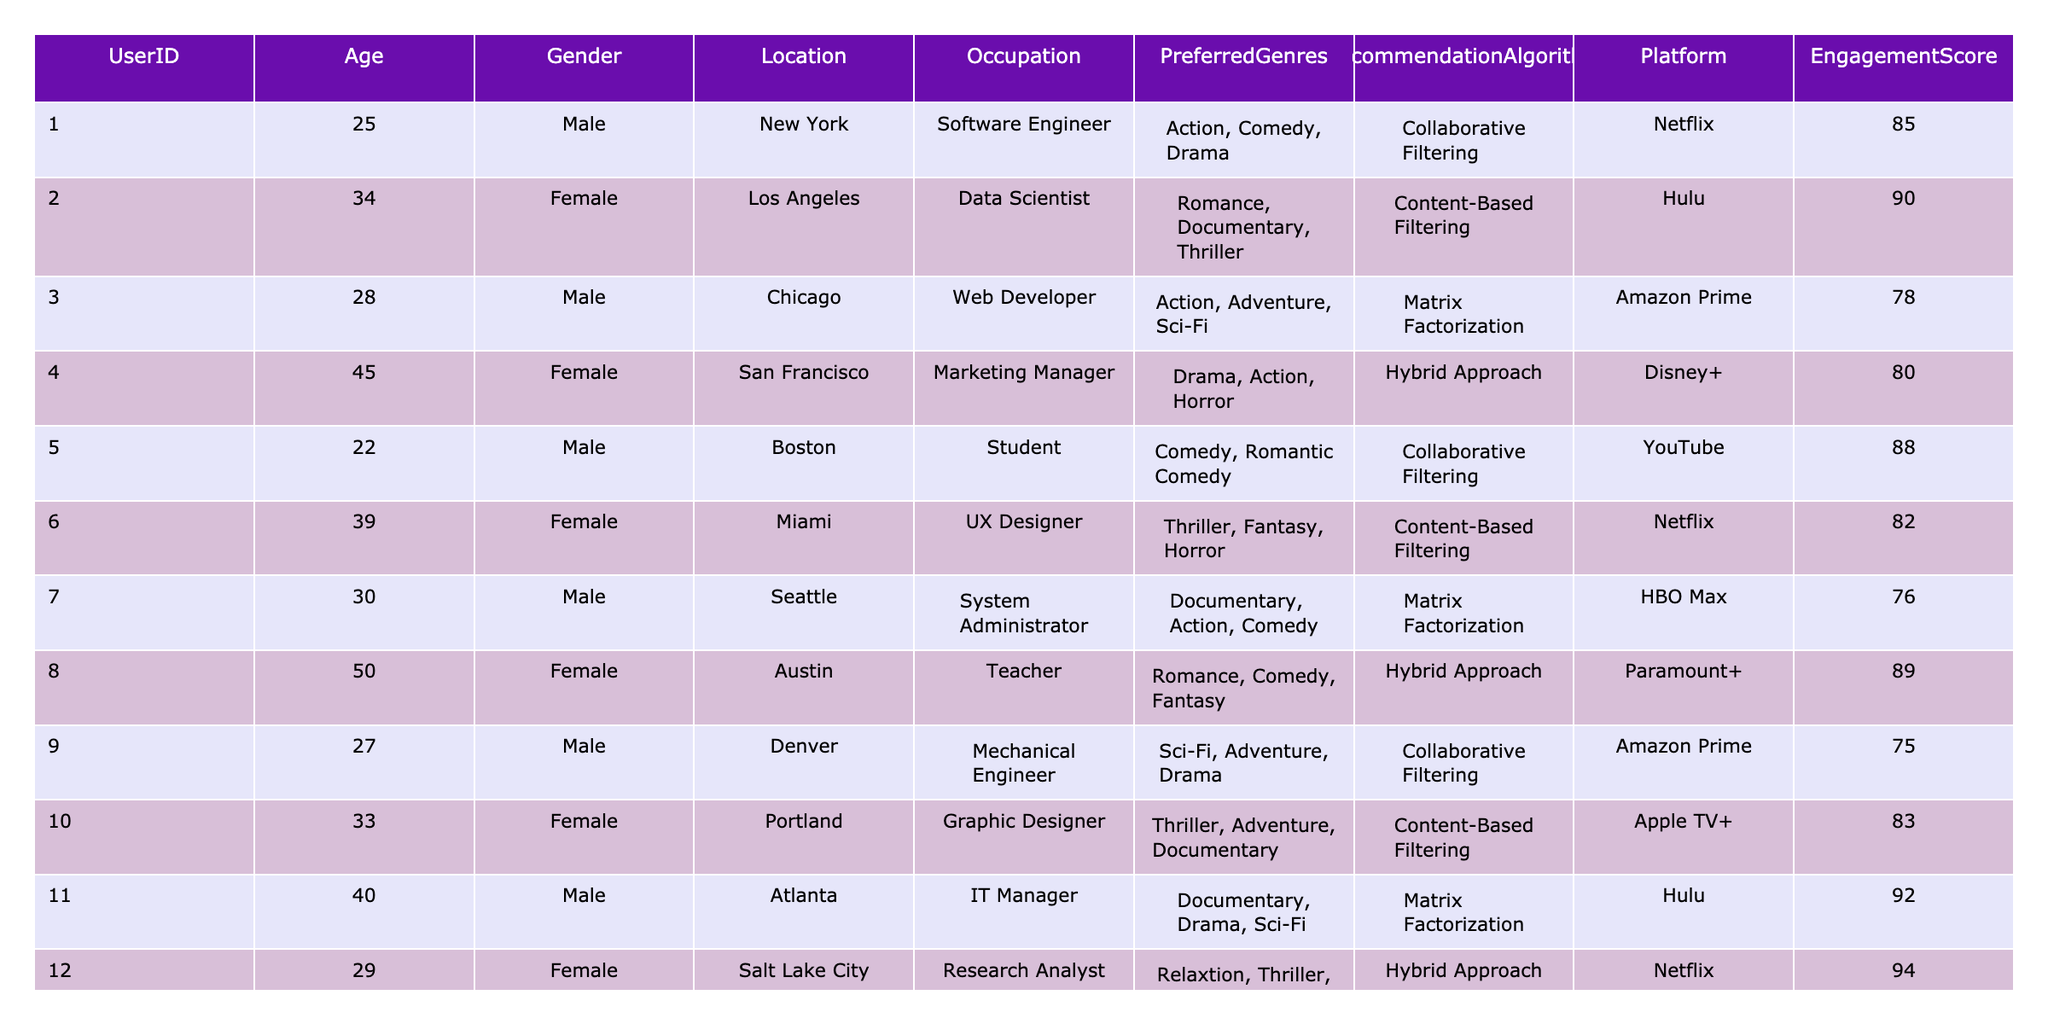What is the most preferred genre among female users? The preferred genres for female users include Romance, Documentary, Thriller, Drama, Horror, Comedy, and Fantasy. By counting these instances, Romance appears most frequently among the preferences listed for specific female users, which are User 2, User 4, User 8, User 10, and User 12.
Answer: Romance How many users prefer the Collaborative Filtering recommendation algorithm? There are five users in the table who use Collaborative Filtering as their recommendation algorithm. They are User 1, User 5, User 9, User 13, and User 15.
Answer: 5 What is the average Engagement Score for users in the age group 30-39? The users aged between 30 and 39 are User 7, User 11, User 12, and User 15. Their Engagement Scores are 76, 92, 94, and 89 respectively. The average Engagement Score is (76 + 92 + 94 + 89) / 4 = 87.75.
Answer: 87.75 Which recommendation algorithm is most popular among those in the Engineering and IT sectors? Occupations related to Engineering and IT are Software Engineer (User 1), Web Developer (User 3), Mechanical Engineer (User 9), and IT Manager (User 11). The recommendation algorithms used by these users are Collaborative Filtering, Matrix Factorization, Collaborative Filtering, and Matrix Factorization, respectively. Both Collaborative Filtering and Matrix Factorization have equal occurrences, but Matrix Factorization is more populous at two instances.
Answer: Matrix Factorization Is there any user with an Engagement Score higher than 90 who uses Content-Based Filtering? Checking the Engagement Scores for users using Content-Based Filtering, we find that User 2 has a score of 90, and all other users using this algorithm have scores lower than 90. Thus, the statement is false as none exceed 90.
Answer: No What is the total number of users who prefer Comedy as one of their genres? Examining the table, Comedy is preferred by Users 5, 8, 10, and 14. The count is four users in total.
Answer: 4 Which city has the highest average Engagement Score based on the table data? To find the city with the highest average Engagement Score, we group by Location and calculate the average score. User 1 from New York has 85, User 2 from Los Angeles has 90, User 3 from Chicago has 78, and so on. After calculating, we find that Los Angeles has the highest average score of 90.
Answer: Los Angeles Do users who prefer Hybrid Approach have a higher average Engagement Score compared to those who prefer Content-Based Filtering? Users using the Hybrid Approach have Engagement Scores of 80, 89, 94, and 89 (totaling 352, average = 88). Users using Content-Based Filtering have scores of 90, 82, and 83 (totaling 255, average = 85). Since 88 is greater than 85, Hybrid Approach users do have a higher average score.
Answer: Yes How many unique preferred genres are there among all users? By listing and counting the genres from all users, the unique genres include Action, Comedy, Drama, Romance, Documentary, Thriller, Adventure, Horror, Fantasy, Mystery, and Relaxation. This results in a total of 11 unique genres.
Answer: 11 Which user's preferred genre lists both Comedy and Drama, and what is their Engagement Score? User 14’s preferred genres are Comedy, Drama, and Thriller, and their Engagement Score is 81.
Answer: User 14, Engagement Score 81 